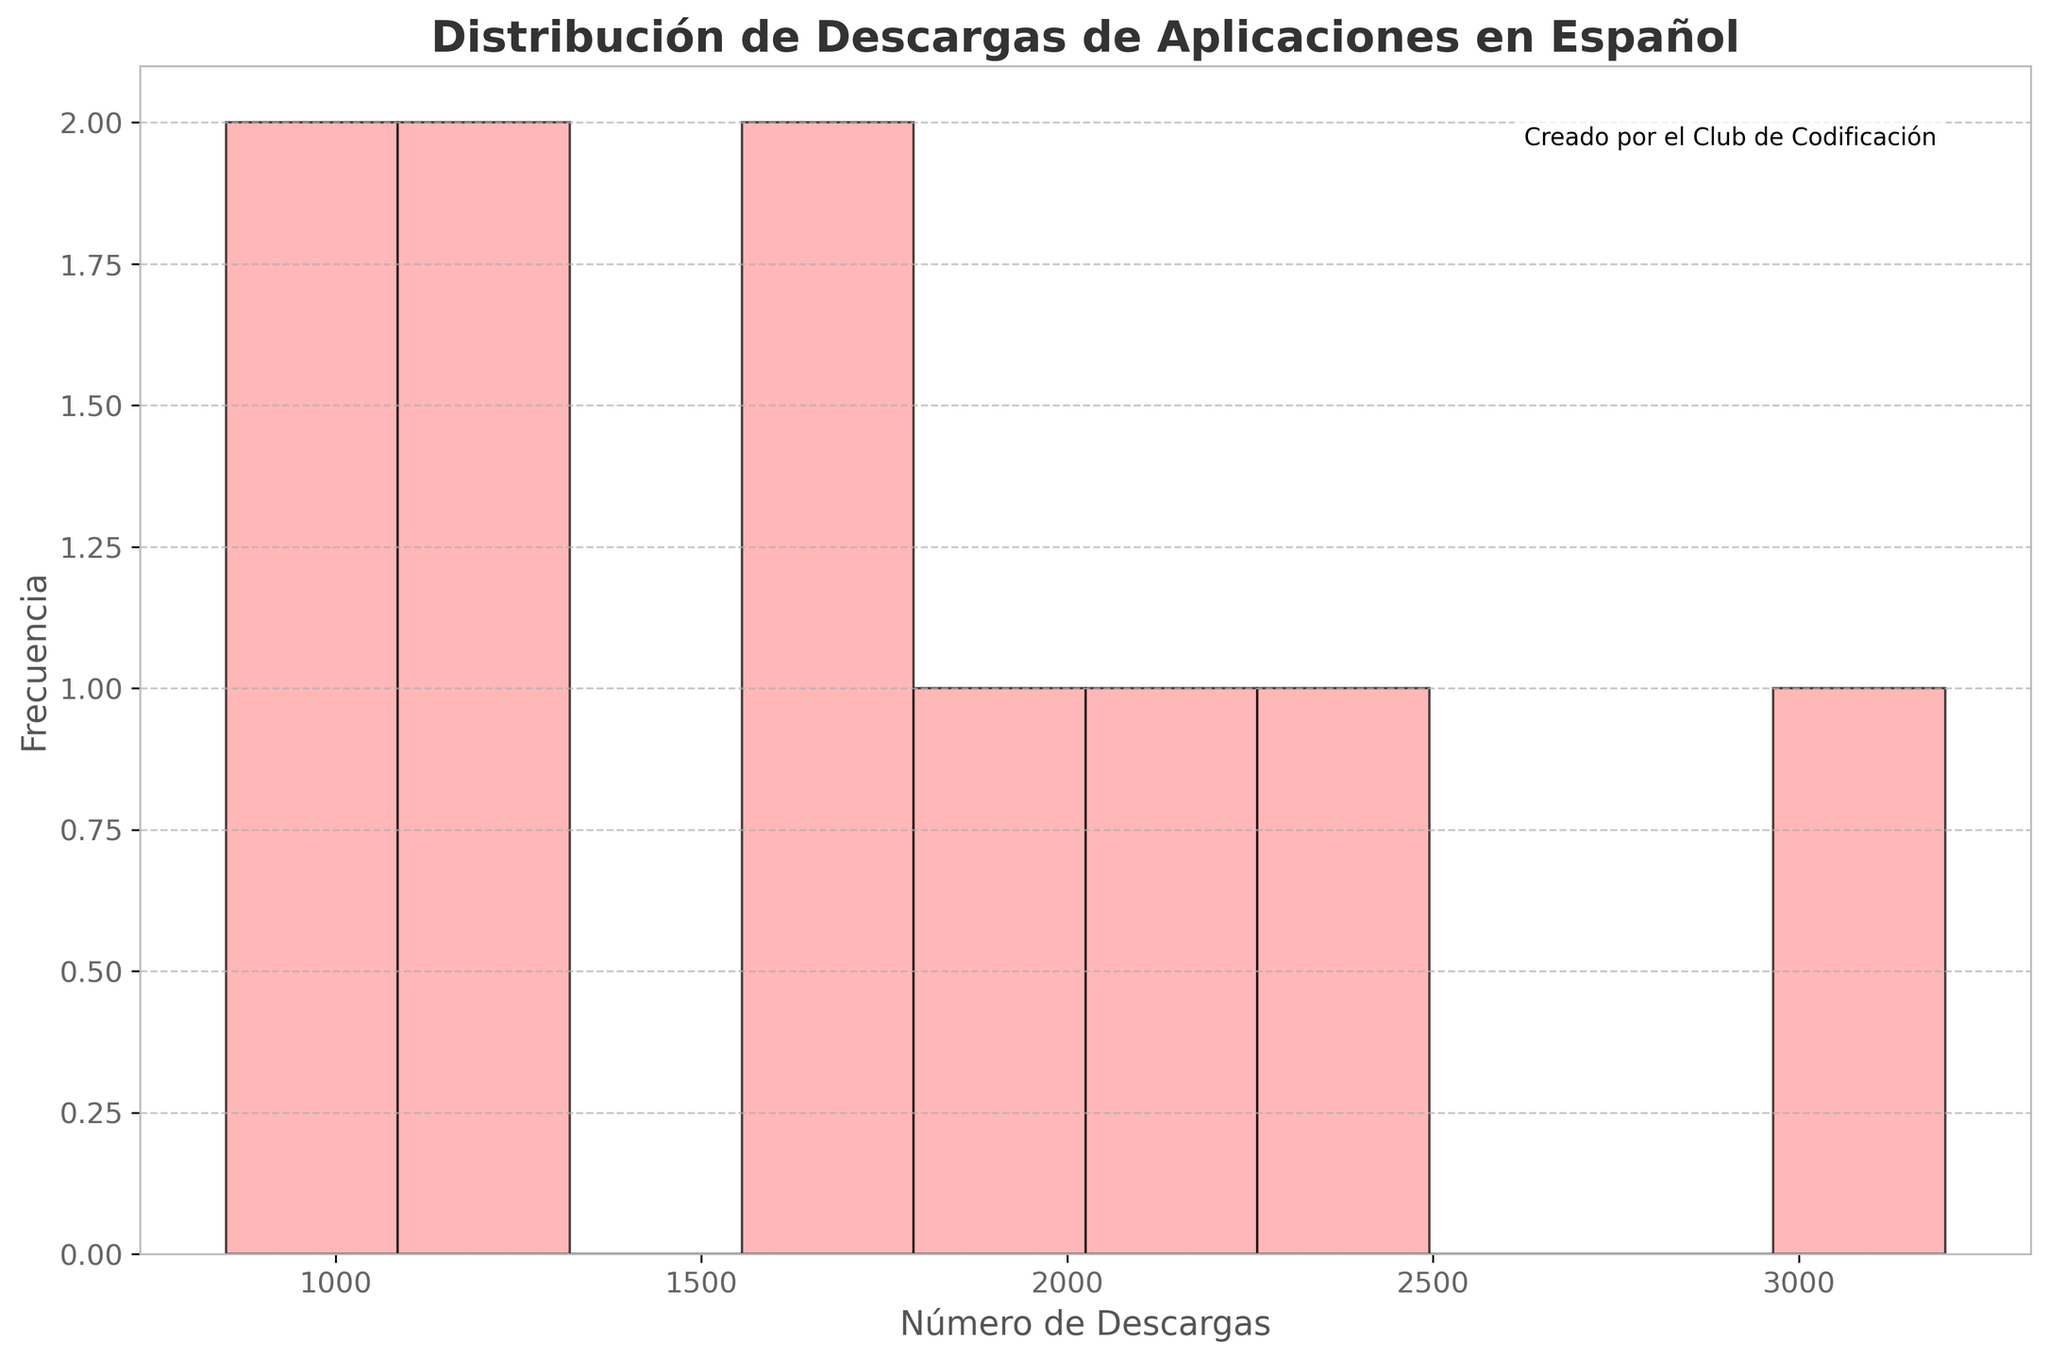What is the title of the histogram? The title of the histogram is usually found at the top of the chart. Here, the title is "Distribución de Descargas de Aplicaciones en Español".
Answer: Distribución de Descargas de Aplicaciones en Español What do the x-axis and y-axis represent? The x-axis represents the "Número de Descargas" which translates to the number of downloads, and the y-axis represents "Frecuencia" which means the frequency or number of apps that fall into each download range.
Answer: Número de Descargas, Frecuencia How many apps have download counts in the range of 500 to 1000? To find this, look at the bar in the histogram that covers the range of 500 to 1000 on the x-axis, and check the height of the bar to see the frequency. There is one bar in this range.
Answer: 1 What app has the highest number of downloads? By looking at the individual data points, "Matemáticas Divertidas" has the highest download count of 3200.
Answer: Matemáticas Divertidas Which download range has the most number of apps? Look for the tallest bar in the histogram. The tallest bar will give the download range with the highest frequency. This is usually the one that falls between 1500 and 2000.
Answer: 1500 to 2000 What is the total number of downloads for all the apps? Sum all the individual download counts: 1250 + 980 + 2100 + 1750 + 850 + 3200 + 1600 + 1100 + 2300 + 1900 = 16930
Answer: 16930 Are there more apps with downloads over 2000 or under 2000? Count the number of apps with downloads greater than 2000 and compare it with those under 2000. There are 4 apps with downloads over 2000 and 6 apps with downloads under 2000.
Answer: Under 2000 What's the average number of downloads across all apps? Calculate the average by summing all download counts and dividing by the number of apps: (1250 + 980 + 2100 + 1750 + 850 + 3200 + 1600 + 1100 + 2300 + 1900) / 10 = 16930 / 10 = 1693
Answer: 1693 What is the download range of most apps? Identify the range with the highest frequency. The range with the most apps is between 1500 and 2000 downloads, as indicated by the tallest histogram bar.
Answer: 1500-2000 Which app falls into the second highest download range? Order the apps by their download counts and identify the second highest. "Batalla de Verbos" falls in the download range of 2300, which is the second highest after "Matemáticas Divertidas".
Answer: Batalla de Verbos 